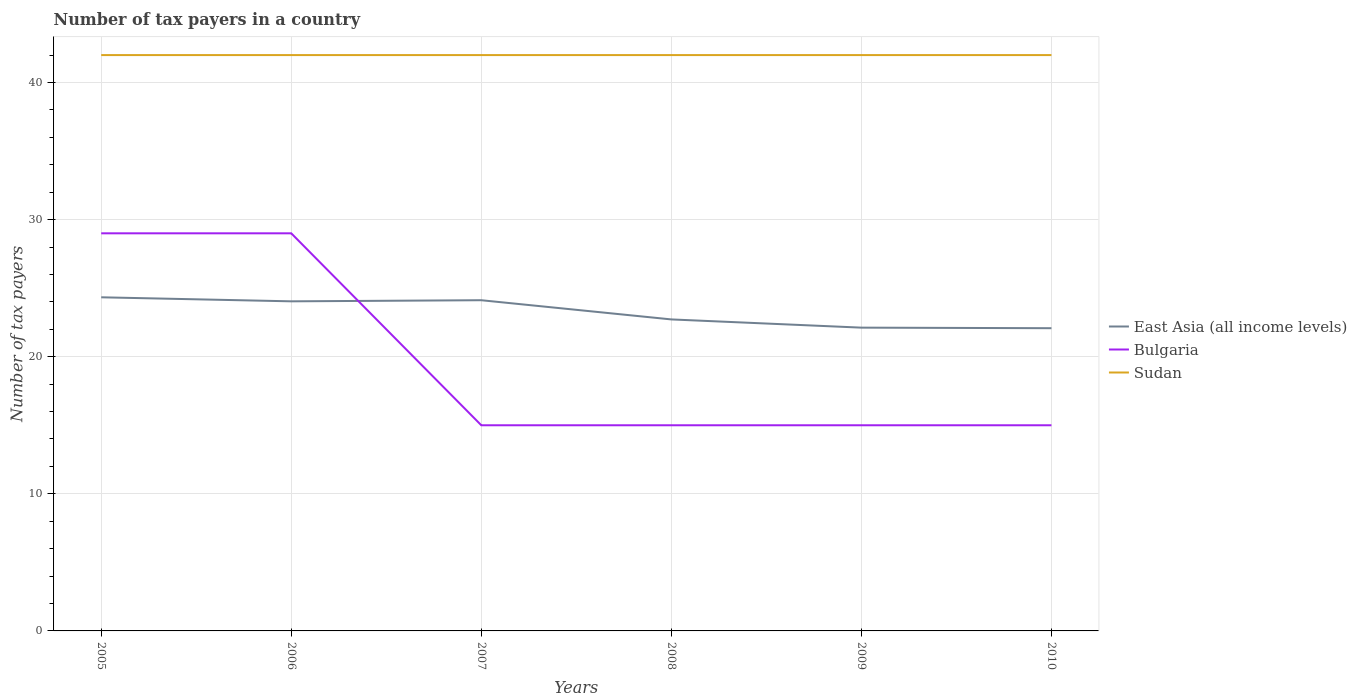How many different coloured lines are there?
Offer a very short reply. 3. Does the line corresponding to East Asia (all income levels) intersect with the line corresponding to Sudan?
Give a very brief answer. No. Across all years, what is the maximum number of tax payers in in Bulgaria?
Ensure brevity in your answer.  15. What is the total number of tax payers in in Bulgaria in the graph?
Your answer should be very brief. 14. Is the number of tax payers in in Sudan strictly greater than the number of tax payers in in East Asia (all income levels) over the years?
Your answer should be compact. No. What is the difference between two consecutive major ticks on the Y-axis?
Provide a short and direct response. 10. Does the graph contain grids?
Ensure brevity in your answer.  Yes. How many legend labels are there?
Offer a very short reply. 3. What is the title of the graph?
Make the answer very short. Number of tax payers in a country. Does "Argentina" appear as one of the legend labels in the graph?
Your answer should be compact. No. What is the label or title of the Y-axis?
Keep it short and to the point. Number of tax payers. What is the Number of tax payers of East Asia (all income levels) in 2005?
Make the answer very short. 24.33. What is the Number of tax payers of Sudan in 2005?
Offer a very short reply. 42. What is the Number of tax payers of East Asia (all income levels) in 2006?
Give a very brief answer. 24.04. What is the Number of tax payers in East Asia (all income levels) in 2007?
Provide a succinct answer. 24.12. What is the Number of tax payers of Bulgaria in 2007?
Provide a succinct answer. 15. What is the Number of tax payers in East Asia (all income levels) in 2008?
Provide a succinct answer. 22.72. What is the Number of tax payers of Sudan in 2008?
Offer a very short reply. 42. What is the Number of tax payers in East Asia (all income levels) in 2009?
Provide a succinct answer. 22.12. What is the Number of tax payers of Sudan in 2009?
Your response must be concise. 42. What is the Number of tax payers of East Asia (all income levels) in 2010?
Make the answer very short. 22.08. What is the Number of tax payers of Bulgaria in 2010?
Provide a succinct answer. 15. What is the Number of tax payers in Sudan in 2010?
Make the answer very short. 42. Across all years, what is the maximum Number of tax payers in East Asia (all income levels)?
Your answer should be very brief. 24.33. Across all years, what is the maximum Number of tax payers of Sudan?
Keep it short and to the point. 42. Across all years, what is the minimum Number of tax payers in East Asia (all income levels)?
Your answer should be very brief. 22.08. Across all years, what is the minimum Number of tax payers in Sudan?
Offer a very short reply. 42. What is the total Number of tax payers in East Asia (all income levels) in the graph?
Your answer should be compact. 139.41. What is the total Number of tax payers in Bulgaria in the graph?
Your answer should be very brief. 118. What is the total Number of tax payers of Sudan in the graph?
Keep it short and to the point. 252. What is the difference between the Number of tax payers in East Asia (all income levels) in 2005 and that in 2006?
Your answer should be very brief. 0.29. What is the difference between the Number of tax payers in East Asia (all income levels) in 2005 and that in 2007?
Offer a terse response. 0.21. What is the difference between the Number of tax payers in Bulgaria in 2005 and that in 2007?
Your response must be concise. 14. What is the difference between the Number of tax payers in East Asia (all income levels) in 2005 and that in 2008?
Give a very brief answer. 1.61. What is the difference between the Number of tax payers in Bulgaria in 2005 and that in 2008?
Give a very brief answer. 14. What is the difference between the Number of tax payers of East Asia (all income levels) in 2005 and that in 2009?
Your answer should be compact. 2.21. What is the difference between the Number of tax payers in Bulgaria in 2005 and that in 2009?
Your answer should be very brief. 14. What is the difference between the Number of tax payers in East Asia (all income levels) in 2005 and that in 2010?
Ensure brevity in your answer.  2.25. What is the difference between the Number of tax payers in Bulgaria in 2005 and that in 2010?
Make the answer very short. 14. What is the difference between the Number of tax payers of Sudan in 2005 and that in 2010?
Your answer should be compact. 0. What is the difference between the Number of tax payers in East Asia (all income levels) in 2006 and that in 2007?
Keep it short and to the point. -0.08. What is the difference between the Number of tax payers in Bulgaria in 2006 and that in 2007?
Your answer should be very brief. 14. What is the difference between the Number of tax payers in Sudan in 2006 and that in 2007?
Provide a succinct answer. 0. What is the difference between the Number of tax payers in East Asia (all income levels) in 2006 and that in 2008?
Your answer should be compact. 1.32. What is the difference between the Number of tax payers of East Asia (all income levels) in 2006 and that in 2009?
Give a very brief answer. 1.92. What is the difference between the Number of tax payers in East Asia (all income levels) in 2006 and that in 2010?
Make the answer very short. 1.96. What is the difference between the Number of tax payers in Bulgaria in 2006 and that in 2010?
Provide a short and direct response. 14. What is the difference between the Number of tax payers in East Asia (all income levels) in 2007 and that in 2008?
Offer a terse response. 1.4. What is the difference between the Number of tax payers in East Asia (all income levels) in 2007 and that in 2009?
Offer a terse response. 2. What is the difference between the Number of tax payers of Sudan in 2007 and that in 2009?
Offer a very short reply. 0. What is the difference between the Number of tax payers in East Asia (all income levels) in 2007 and that in 2010?
Give a very brief answer. 2.04. What is the difference between the Number of tax payers in East Asia (all income levels) in 2008 and that in 2009?
Give a very brief answer. 0.6. What is the difference between the Number of tax payers in East Asia (all income levels) in 2008 and that in 2010?
Keep it short and to the point. 0.64. What is the difference between the Number of tax payers of East Asia (all income levels) in 2009 and that in 2010?
Give a very brief answer. 0.04. What is the difference between the Number of tax payers in East Asia (all income levels) in 2005 and the Number of tax payers in Bulgaria in 2006?
Your response must be concise. -4.67. What is the difference between the Number of tax payers of East Asia (all income levels) in 2005 and the Number of tax payers of Sudan in 2006?
Provide a short and direct response. -17.67. What is the difference between the Number of tax payers in Bulgaria in 2005 and the Number of tax payers in Sudan in 2006?
Offer a very short reply. -13. What is the difference between the Number of tax payers in East Asia (all income levels) in 2005 and the Number of tax payers in Bulgaria in 2007?
Give a very brief answer. 9.33. What is the difference between the Number of tax payers of East Asia (all income levels) in 2005 and the Number of tax payers of Sudan in 2007?
Your response must be concise. -17.67. What is the difference between the Number of tax payers in East Asia (all income levels) in 2005 and the Number of tax payers in Bulgaria in 2008?
Ensure brevity in your answer.  9.33. What is the difference between the Number of tax payers of East Asia (all income levels) in 2005 and the Number of tax payers of Sudan in 2008?
Your answer should be very brief. -17.67. What is the difference between the Number of tax payers of Bulgaria in 2005 and the Number of tax payers of Sudan in 2008?
Offer a terse response. -13. What is the difference between the Number of tax payers in East Asia (all income levels) in 2005 and the Number of tax payers in Bulgaria in 2009?
Offer a very short reply. 9.33. What is the difference between the Number of tax payers of East Asia (all income levels) in 2005 and the Number of tax payers of Sudan in 2009?
Provide a succinct answer. -17.67. What is the difference between the Number of tax payers in East Asia (all income levels) in 2005 and the Number of tax payers in Bulgaria in 2010?
Provide a succinct answer. 9.33. What is the difference between the Number of tax payers of East Asia (all income levels) in 2005 and the Number of tax payers of Sudan in 2010?
Offer a very short reply. -17.67. What is the difference between the Number of tax payers in East Asia (all income levels) in 2006 and the Number of tax payers in Bulgaria in 2007?
Provide a short and direct response. 9.04. What is the difference between the Number of tax payers in East Asia (all income levels) in 2006 and the Number of tax payers in Sudan in 2007?
Offer a very short reply. -17.96. What is the difference between the Number of tax payers in Bulgaria in 2006 and the Number of tax payers in Sudan in 2007?
Give a very brief answer. -13. What is the difference between the Number of tax payers of East Asia (all income levels) in 2006 and the Number of tax payers of Bulgaria in 2008?
Keep it short and to the point. 9.04. What is the difference between the Number of tax payers in East Asia (all income levels) in 2006 and the Number of tax payers in Sudan in 2008?
Provide a succinct answer. -17.96. What is the difference between the Number of tax payers of East Asia (all income levels) in 2006 and the Number of tax payers of Bulgaria in 2009?
Offer a very short reply. 9.04. What is the difference between the Number of tax payers of East Asia (all income levels) in 2006 and the Number of tax payers of Sudan in 2009?
Your answer should be compact. -17.96. What is the difference between the Number of tax payers in Bulgaria in 2006 and the Number of tax payers in Sudan in 2009?
Offer a terse response. -13. What is the difference between the Number of tax payers in East Asia (all income levels) in 2006 and the Number of tax payers in Bulgaria in 2010?
Provide a succinct answer. 9.04. What is the difference between the Number of tax payers of East Asia (all income levels) in 2006 and the Number of tax payers of Sudan in 2010?
Offer a very short reply. -17.96. What is the difference between the Number of tax payers of East Asia (all income levels) in 2007 and the Number of tax payers of Bulgaria in 2008?
Keep it short and to the point. 9.12. What is the difference between the Number of tax payers in East Asia (all income levels) in 2007 and the Number of tax payers in Sudan in 2008?
Make the answer very short. -17.88. What is the difference between the Number of tax payers of Bulgaria in 2007 and the Number of tax payers of Sudan in 2008?
Make the answer very short. -27. What is the difference between the Number of tax payers in East Asia (all income levels) in 2007 and the Number of tax payers in Bulgaria in 2009?
Keep it short and to the point. 9.12. What is the difference between the Number of tax payers in East Asia (all income levels) in 2007 and the Number of tax payers in Sudan in 2009?
Provide a short and direct response. -17.88. What is the difference between the Number of tax payers of East Asia (all income levels) in 2007 and the Number of tax payers of Bulgaria in 2010?
Offer a very short reply. 9.12. What is the difference between the Number of tax payers of East Asia (all income levels) in 2007 and the Number of tax payers of Sudan in 2010?
Provide a succinct answer. -17.88. What is the difference between the Number of tax payers of Bulgaria in 2007 and the Number of tax payers of Sudan in 2010?
Your answer should be very brief. -27. What is the difference between the Number of tax payers of East Asia (all income levels) in 2008 and the Number of tax payers of Bulgaria in 2009?
Provide a short and direct response. 7.72. What is the difference between the Number of tax payers in East Asia (all income levels) in 2008 and the Number of tax payers in Sudan in 2009?
Provide a short and direct response. -19.28. What is the difference between the Number of tax payers of Bulgaria in 2008 and the Number of tax payers of Sudan in 2009?
Provide a succinct answer. -27. What is the difference between the Number of tax payers in East Asia (all income levels) in 2008 and the Number of tax payers in Bulgaria in 2010?
Ensure brevity in your answer.  7.72. What is the difference between the Number of tax payers of East Asia (all income levels) in 2008 and the Number of tax payers of Sudan in 2010?
Offer a terse response. -19.28. What is the difference between the Number of tax payers in Bulgaria in 2008 and the Number of tax payers in Sudan in 2010?
Provide a succinct answer. -27. What is the difference between the Number of tax payers in East Asia (all income levels) in 2009 and the Number of tax payers in Bulgaria in 2010?
Give a very brief answer. 7.12. What is the difference between the Number of tax payers in East Asia (all income levels) in 2009 and the Number of tax payers in Sudan in 2010?
Give a very brief answer. -19.88. What is the difference between the Number of tax payers of Bulgaria in 2009 and the Number of tax payers of Sudan in 2010?
Your answer should be compact. -27. What is the average Number of tax payers in East Asia (all income levels) per year?
Offer a terse response. 23.24. What is the average Number of tax payers in Bulgaria per year?
Your answer should be very brief. 19.67. What is the average Number of tax payers in Sudan per year?
Ensure brevity in your answer.  42. In the year 2005, what is the difference between the Number of tax payers of East Asia (all income levels) and Number of tax payers of Bulgaria?
Provide a short and direct response. -4.67. In the year 2005, what is the difference between the Number of tax payers in East Asia (all income levels) and Number of tax payers in Sudan?
Your response must be concise. -17.67. In the year 2006, what is the difference between the Number of tax payers in East Asia (all income levels) and Number of tax payers in Bulgaria?
Your answer should be compact. -4.96. In the year 2006, what is the difference between the Number of tax payers of East Asia (all income levels) and Number of tax payers of Sudan?
Provide a succinct answer. -17.96. In the year 2007, what is the difference between the Number of tax payers of East Asia (all income levels) and Number of tax payers of Bulgaria?
Provide a short and direct response. 9.12. In the year 2007, what is the difference between the Number of tax payers of East Asia (all income levels) and Number of tax payers of Sudan?
Offer a very short reply. -17.88. In the year 2008, what is the difference between the Number of tax payers of East Asia (all income levels) and Number of tax payers of Bulgaria?
Give a very brief answer. 7.72. In the year 2008, what is the difference between the Number of tax payers in East Asia (all income levels) and Number of tax payers in Sudan?
Give a very brief answer. -19.28. In the year 2008, what is the difference between the Number of tax payers in Bulgaria and Number of tax payers in Sudan?
Your answer should be very brief. -27. In the year 2009, what is the difference between the Number of tax payers in East Asia (all income levels) and Number of tax payers in Bulgaria?
Provide a succinct answer. 7.12. In the year 2009, what is the difference between the Number of tax payers in East Asia (all income levels) and Number of tax payers in Sudan?
Offer a terse response. -19.88. In the year 2009, what is the difference between the Number of tax payers in Bulgaria and Number of tax payers in Sudan?
Your answer should be compact. -27. In the year 2010, what is the difference between the Number of tax payers of East Asia (all income levels) and Number of tax payers of Bulgaria?
Give a very brief answer. 7.08. In the year 2010, what is the difference between the Number of tax payers in East Asia (all income levels) and Number of tax payers in Sudan?
Your answer should be compact. -19.92. What is the ratio of the Number of tax payers in East Asia (all income levels) in 2005 to that in 2006?
Offer a very short reply. 1.01. What is the ratio of the Number of tax payers of East Asia (all income levels) in 2005 to that in 2007?
Provide a short and direct response. 1.01. What is the ratio of the Number of tax payers of Bulgaria in 2005 to that in 2007?
Your answer should be compact. 1.93. What is the ratio of the Number of tax payers of Sudan in 2005 to that in 2007?
Your response must be concise. 1. What is the ratio of the Number of tax payers in East Asia (all income levels) in 2005 to that in 2008?
Your response must be concise. 1.07. What is the ratio of the Number of tax payers of Bulgaria in 2005 to that in 2008?
Offer a very short reply. 1.93. What is the ratio of the Number of tax payers in Sudan in 2005 to that in 2008?
Your answer should be compact. 1. What is the ratio of the Number of tax payers of East Asia (all income levels) in 2005 to that in 2009?
Your answer should be compact. 1.1. What is the ratio of the Number of tax payers of Bulgaria in 2005 to that in 2009?
Your response must be concise. 1.93. What is the ratio of the Number of tax payers of East Asia (all income levels) in 2005 to that in 2010?
Your answer should be very brief. 1.1. What is the ratio of the Number of tax payers in Bulgaria in 2005 to that in 2010?
Ensure brevity in your answer.  1.93. What is the ratio of the Number of tax payers in Sudan in 2005 to that in 2010?
Make the answer very short. 1. What is the ratio of the Number of tax payers of East Asia (all income levels) in 2006 to that in 2007?
Offer a terse response. 1. What is the ratio of the Number of tax payers in Bulgaria in 2006 to that in 2007?
Ensure brevity in your answer.  1.93. What is the ratio of the Number of tax payers of Sudan in 2006 to that in 2007?
Your answer should be very brief. 1. What is the ratio of the Number of tax payers of East Asia (all income levels) in 2006 to that in 2008?
Keep it short and to the point. 1.06. What is the ratio of the Number of tax payers of Bulgaria in 2006 to that in 2008?
Your answer should be compact. 1.93. What is the ratio of the Number of tax payers of East Asia (all income levels) in 2006 to that in 2009?
Your answer should be very brief. 1.09. What is the ratio of the Number of tax payers of Bulgaria in 2006 to that in 2009?
Ensure brevity in your answer.  1.93. What is the ratio of the Number of tax payers in Sudan in 2006 to that in 2009?
Give a very brief answer. 1. What is the ratio of the Number of tax payers in East Asia (all income levels) in 2006 to that in 2010?
Give a very brief answer. 1.09. What is the ratio of the Number of tax payers in Bulgaria in 2006 to that in 2010?
Offer a very short reply. 1.93. What is the ratio of the Number of tax payers of East Asia (all income levels) in 2007 to that in 2008?
Give a very brief answer. 1.06. What is the ratio of the Number of tax payers in East Asia (all income levels) in 2007 to that in 2009?
Ensure brevity in your answer.  1.09. What is the ratio of the Number of tax payers in Bulgaria in 2007 to that in 2009?
Your response must be concise. 1. What is the ratio of the Number of tax payers of East Asia (all income levels) in 2007 to that in 2010?
Provide a succinct answer. 1.09. What is the ratio of the Number of tax payers in East Asia (all income levels) in 2008 to that in 2009?
Give a very brief answer. 1.03. What is the ratio of the Number of tax payers of Sudan in 2008 to that in 2009?
Your answer should be compact. 1. What is the ratio of the Number of tax payers of Bulgaria in 2008 to that in 2010?
Offer a terse response. 1. What is the ratio of the Number of tax payers of Sudan in 2009 to that in 2010?
Your answer should be compact. 1. What is the difference between the highest and the second highest Number of tax payers of East Asia (all income levels)?
Offer a very short reply. 0.21. What is the difference between the highest and the second highest Number of tax payers in Bulgaria?
Provide a succinct answer. 0. What is the difference between the highest and the lowest Number of tax payers of East Asia (all income levels)?
Make the answer very short. 2.25. 